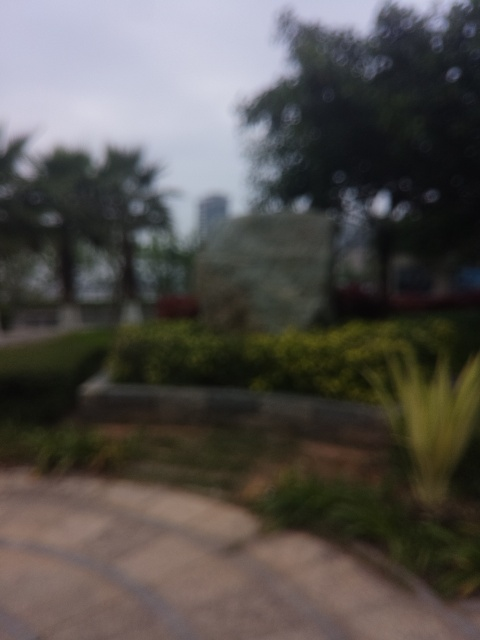What kind of environment does the stone carving appear to be in? The stone carving appears to be located outdoors, surrounded by vegetation such as bushes and possibly set within a park or garden-like setting. The presence of greenery suggests a tranquil atmosphere. 